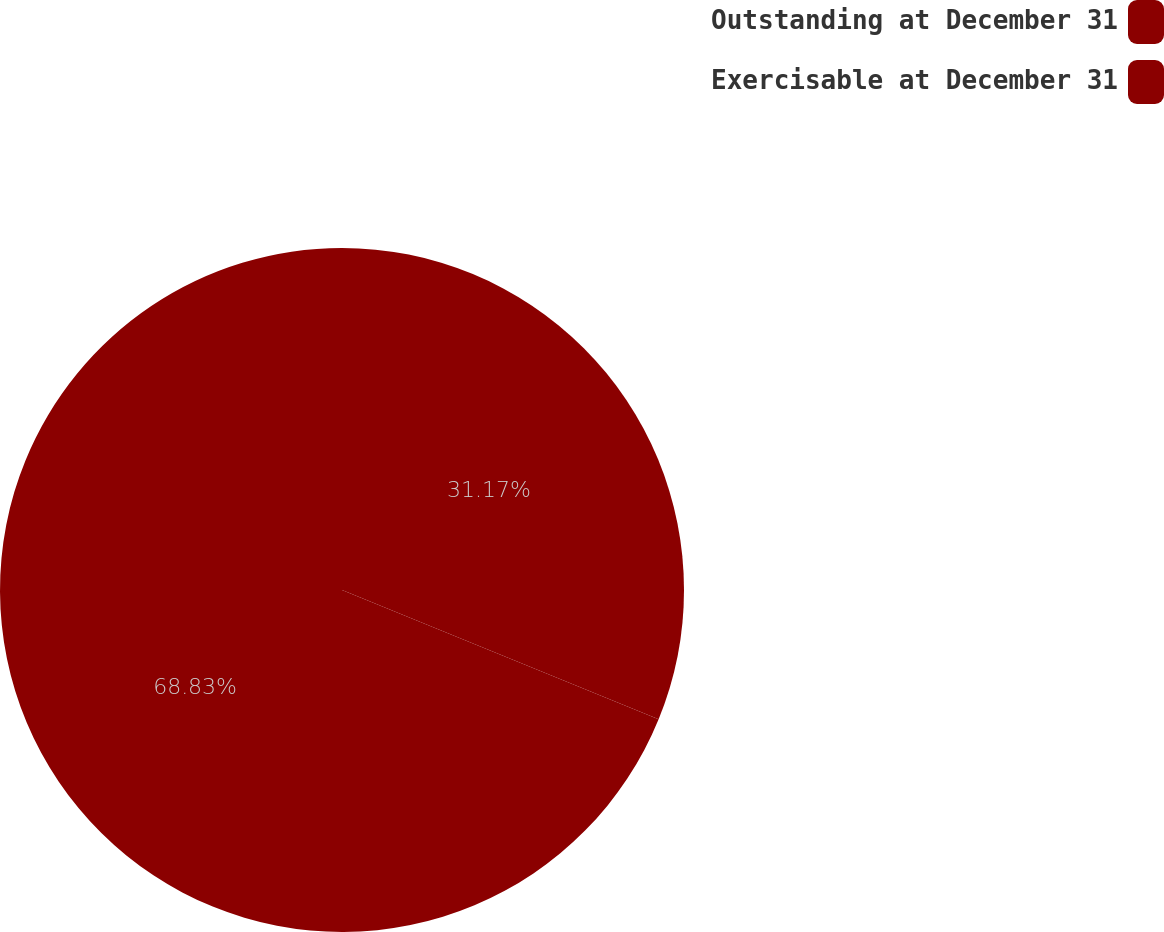Convert chart to OTSL. <chart><loc_0><loc_0><loc_500><loc_500><pie_chart><fcel>Outstanding at December 31<fcel>Exercisable at December 31<nl><fcel>31.17%<fcel>68.83%<nl></chart> 